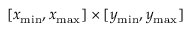Convert formula to latex. <formula><loc_0><loc_0><loc_500><loc_500>[ x _ { \min } , x _ { \max } ] \times [ y _ { \min } , y _ { \max } ]</formula> 